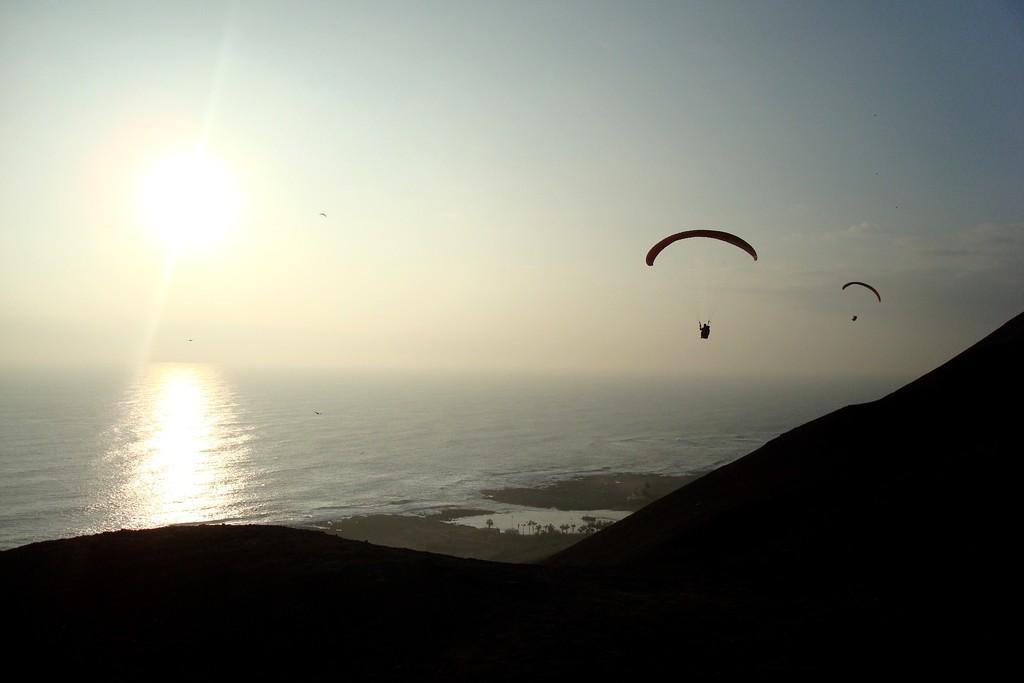Describe this image in one or two sentences. In this image I can see two paragliders flying in air, under that there is some water and mountain. 